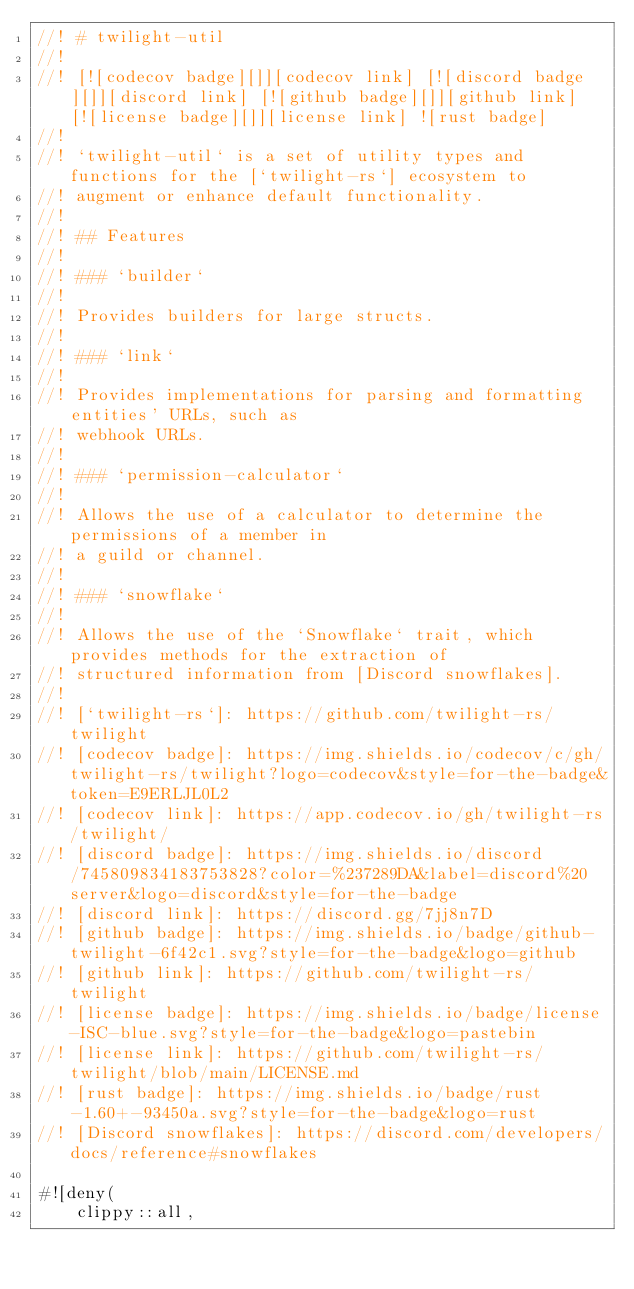Convert code to text. <code><loc_0><loc_0><loc_500><loc_500><_Rust_>//! # twilight-util
//!
//! [![codecov badge][]][codecov link] [![discord badge][]][discord link] [![github badge][]][github link] [![license badge][]][license link] ![rust badge]
//!
//! `twilight-util` is a set of utility types and functions for the [`twilight-rs`] ecosystem to
//! augment or enhance default functionality.
//!
//! ## Features
//!
//! ### `builder`
//!
//! Provides builders for large structs.
//!
//! ### `link`
//!
//! Provides implementations for parsing and formatting entities' URLs, such as
//! webhook URLs.
//!
//! ### `permission-calculator`
//!
//! Allows the use of a calculator to determine the permissions of a member in
//! a guild or channel.
//!
//! ### `snowflake`
//!
//! Allows the use of the `Snowflake` trait, which provides methods for the extraction of
//! structured information from [Discord snowflakes].
//!
//! [`twilight-rs`]: https://github.com/twilight-rs/twilight
//! [codecov badge]: https://img.shields.io/codecov/c/gh/twilight-rs/twilight?logo=codecov&style=for-the-badge&token=E9ERLJL0L2
//! [codecov link]: https://app.codecov.io/gh/twilight-rs/twilight/
//! [discord badge]: https://img.shields.io/discord/745809834183753828?color=%237289DA&label=discord%20server&logo=discord&style=for-the-badge
//! [discord link]: https://discord.gg/7jj8n7D
//! [github badge]: https://img.shields.io/badge/github-twilight-6f42c1.svg?style=for-the-badge&logo=github
//! [github link]: https://github.com/twilight-rs/twilight
//! [license badge]: https://img.shields.io/badge/license-ISC-blue.svg?style=for-the-badge&logo=pastebin
//! [license link]: https://github.com/twilight-rs/twilight/blob/main/LICENSE.md
//! [rust badge]: https://img.shields.io/badge/rust-1.60+-93450a.svg?style=for-the-badge&logo=rust
//! [Discord snowflakes]: https://discord.com/developers/docs/reference#snowflakes

#![deny(
    clippy::all,</code> 